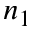<formula> <loc_0><loc_0><loc_500><loc_500>n _ { 1 }</formula> 